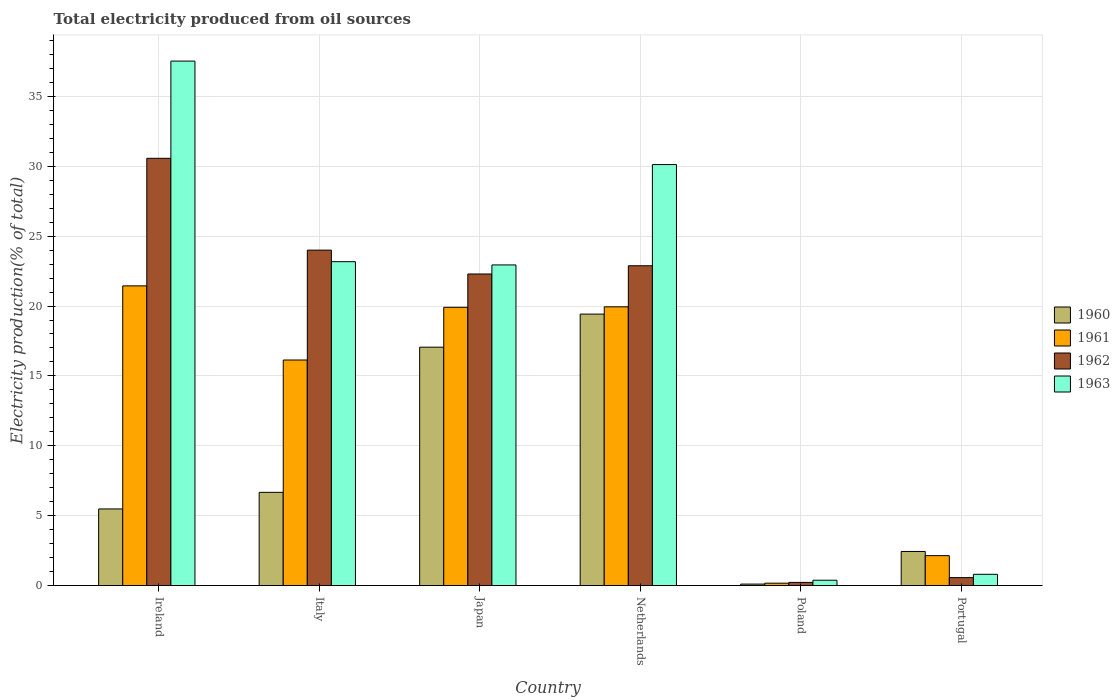How many bars are there on the 3rd tick from the left?
Your answer should be compact. 4. How many bars are there on the 4th tick from the right?
Your response must be concise. 4. What is the label of the 2nd group of bars from the left?
Make the answer very short. Italy. What is the total electricity produced in 1961 in Ireland?
Offer a very short reply. 21.44. Across all countries, what is the maximum total electricity produced in 1962?
Your response must be concise. 30.57. Across all countries, what is the minimum total electricity produced in 1961?
Your answer should be very brief. 0.17. What is the total total electricity produced in 1962 in the graph?
Offer a terse response. 100.54. What is the difference between the total electricity produced in 1961 in Netherlands and that in Portugal?
Offer a very short reply. 17.8. What is the difference between the total electricity produced in 1963 in Portugal and the total electricity produced in 1962 in Netherlands?
Your answer should be very brief. -22.08. What is the average total electricity produced in 1960 per country?
Your answer should be very brief. 8.53. What is the difference between the total electricity produced of/in 1962 and total electricity produced of/in 1961 in Japan?
Offer a terse response. 2.38. What is the ratio of the total electricity produced in 1963 in Japan to that in Netherlands?
Your answer should be very brief. 0.76. Is the total electricity produced in 1961 in Ireland less than that in Poland?
Offer a terse response. No. What is the difference between the highest and the second highest total electricity produced in 1963?
Your response must be concise. 7.4. What is the difference between the highest and the lowest total electricity produced in 1963?
Your answer should be very brief. 37.14. Is the sum of the total electricity produced in 1961 in Italy and Netherlands greater than the maximum total electricity produced in 1962 across all countries?
Keep it short and to the point. Yes. Is it the case that in every country, the sum of the total electricity produced in 1962 and total electricity produced in 1960 is greater than the sum of total electricity produced in 1963 and total electricity produced in 1961?
Your answer should be very brief. No. What does the 3rd bar from the left in Ireland represents?
Make the answer very short. 1962. Is it the case that in every country, the sum of the total electricity produced in 1963 and total electricity produced in 1961 is greater than the total electricity produced in 1960?
Your answer should be compact. Yes. Where does the legend appear in the graph?
Ensure brevity in your answer.  Center right. How are the legend labels stacked?
Make the answer very short. Vertical. What is the title of the graph?
Offer a terse response. Total electricity produced from oil sources. Does "2012" appear as one of the legend labels in the graph?
Offer a very short reply. No. What is the label or title of the Y-axis?
Provide a short and direct response. Electricity production(% of total). What is the Electricity production(% of total) of 1960 in Ireland?
Offer a very short reply. 5.48. What is the Electricity production(% of total) of 1961 in Ireland?
Offer a very short reply. 21.44. What is the Electricity production(% of total) of 1962 in Ireland?
Make the answer very short. 30.57. What is the Electricity production(% of total) of 1963 in Ireland?
Provide a short and direct response. 37.53. What is the Electricity production(% of total) in 1960 in Italy?
Your answer should be very brief. 6.67. What is the Electricity production(% of total) in 1961 in Italy?
Offer a very short reply. 16.14. What is the Electricity production(% of total) of 1962 in Italy?
Provide a succinct answer. 24. What is the Electricity production(% of total) in 1963 in Italy?
Keep it short and to the point. 23.17. What is the Electricity production(% of total) in 1960 in Japan?
Make the answer very short. 17.06. What is the Electricity production(% of total) in 1961 in Japan?
Ensure brevity in your answer.  19.91. What is the Electricity production(% of total) of 1962 in Japan?
Provide a short and direct response. 22.29. What is the Electricity production(% of total) of 1963 in Japan?
Provide a succinct answer. 22.94. What is the Electricity production(% of total) of 1960 in Netherlands?
Offer a very short reply. 19.42. What is the Electricity production(% of total) of 1961 in Netherlands?
Give a very brief answer. 19.94. What is the Electricity production(% of total) in 1962 in Netherlands?
Offer a very short reply. 22.88. What is the Electricity production(% of total) of 1963 in Netherlands?
Provide a succinct answer. 30.12. What is the Electricity production(% of total) of 1960 in Poland?
Give a very brief answer. 0.11. What is the Electricity production(% of total) of 1961 in Poland?
Your answer should be very brief. 0.17. What is the Electricity production(% of total) of 1962 in Poland?
Your answer should be very brief. 0.23. What is the Electricity production(% of total) in 1963 in Poland?
Your response must be concise. 0.38. What is the Electricity production(% of total) in 1960 in Portugal?
Your answer should be compact. 2.44. What is the Electricity production(% of total) in 1961 in Portugal?
Keep it short and to the point. 2.14. What is the Electricity production(% of total) of 1962 in Portugal?
Your answer should be compact. 0.57. What is the Electricity production(% of total) in 1963 in Portugal?
Ensure brevity in your answer.  0.81. Across all countries, what is the maximum Electricity production(% of total) of 1960?
Provide a succinct answer. 19.42. Across all countries, what is the maximum Electricity production(% of total) in 1961?
Make the answer very short. 21.44. Across all countries, what is the maximum Electricity production(% of total) of 1962?
Make the answer very short. 30.57. Across all countries, what is the maximum Electricity production(% of total) in 1963?
Ensure brevity in your answer.  37.53. Across all countries, what is the minimum Electricity production(% of total) of 1960?
Give a very brief answer. 0.11. Across all countries, what is the minimum Electricity production(% of total) in 1961?
Provide a short and direct response. 0.17. Across all countries, what is the minimum Electricity production(% of total) in 1962?
Provide a short and direct response. 0.23. Across all countries, what is the minimum Electricity production(% of total) in 1963?
Give a very brief answer. 0.38. What is the total Electricity production(% of total) in 1960 in the graph?
Make the answer very short. 51.18. What is the total Electricity production(% of total) of 1961 in the graph?
Offer a terse response. 79.75. What is the total Electricity production(% of total) of 1962 in the graph?
Provide a succinct answer. 100.54. What is the total Electricity production(% of total) in 1963 in the graph?
Provide a short and direct response. 114.95. What is the difference between the Electricity production(% of total) in 1960 in Ireland and that in Italy?
Your answer should be compact. -1.19. What is the difference between the Electricity production(% of total) in 1961 in Ireland and that in Italy?
Keep it short and to the point. 5.3. What is the difference between the Electricity production(% of total) of 1962 in Ireland and that in Italy?
Ensure brevity in your answer.  6.57. What is the difference between the Electricity production(% of total) of 1963 in Ireland and that in Italy?
Ensure brevity in your answer.  14.35. What is the difference between the Electricity production(% of total) of 1960 in Ireland and that in Japan?
Make the answer very short. -11.57. What is the difference between the Electricity production(% of total) in 1961 in Ireland and that in Japan?
Provide a short and direct response. 1.53. What is the difference between the Electricity production(% of total) of 1962 in Ireland and that in Japan?
Offer a terse response. 8.28. What is the difference between the Electricity production(% of total) of 1963 in Ireland and that in Japan?
Provide a succinct answer. 14.58. What is the difference between the Electricity production(% of total) of 1960 in Ireland and that in Netherlands?
Your answer should be very brief. -13.94. What is the difference between the Electricity production(% of total) of 1961 in Ireland and that in Netherlands?
Give a very brief answer. 1.5. What is the difference between the Electricity production(% of total) of 1962 in Ireland and that in Netherlands?
Provide a succinct answer. 7.69. What is the difference between the Electricity production(% of total) of 1963 in Ireland and that in Netherlands?
Offer a very short reply. 7.4. What is the difference between the Electricity production(% of total) of 1960 in Ireland and that in Poland?
Give a very brief answer. 5.38. What is the difference between the Electricity production(% of total) of 1961 in Ireland and that in Poland?
Provide a succinct answer. 21.27. What is the difference between the Electricity production(% of total) in 1962 in Ireland and that in Poland?
Give a very brief answer. 30.34. What is the difference between the Electricity production(% of total) in 1963 in Ireland and that in Poland?
Ensure brevity in your answer.  37.14. What is the difference between the Electricity production(% of total) of 1960 in Ireland and that in Portugal?
Your answer should be compact. 3.04. What is the difference between the Electricity production(% of total) in 1961 in Ireland and that in Portugal?
Your response must be concise. 19.3. What is the difference between the Electricity production(% of total) in 1962 in Ireland and that in Portugal?
Your answer should be compact. 30. What is the difference between the Electricity production(% of total) in 1963 in Ireland and that in Portugal?
Provide a short and direct response. 36.72. What is the difference between the Electricity production(% of total) in 1960 in Italy and that in Japan?
Provide a succinct answer. -10.39. What is the difference between the Electricity production(% of total) in 1961 in Italy and that in Japan?
Your answer should be very brief. -3.77. What is the difference between the Electricity production(% of total) in 1962 in Italy and that in Japan?
Give a very brief answer. 1.71. What is the difference between the Electricity production(% of total) in 1963 in Italy and that in Japan?
Your answer should be very brief. 0.23. What is the difference between the Electricity production(% of total) in 1960 in Italy and that in Netherlands?
Give a very brief answer. -12.75. What is the difference between the Electricity production(% of total) of 1961 in Italy and that in Netherlands?
Ensure brevity in your answer.  -3.81. What is the difference between the Electricity production(% of total) of 1962 in Italy and that in Netherlands?
Provide a succinct answer. 1.12. What is the difference between the Electricity production(% of total) of 1963 in Italy and that in Netherlands?
Your answer should be compact. -6.95. What is the difference between the Electricity production(% of total) in 1960 in Italy and that in Poland?
Your answer should be compact. 6.57. What is the difference between the Electricity production(% of total) in 1961 in Italy and that in Poland?
Make the answer very short. 15.97. What is the difference between the Electricity production(% of total) in 1962 in Italy and that in Poland?
Ensure brevity in your answer.  23.77. What is the difference between the Electricity production(% of total) in 1963 in Italy and that in Poland?
Your answer should be compact. 22.79. What is the difference between the Electricity production(% of total) of 1960 in Italy and that in Portugal?
Offer a very short reply. 4.23. What is the difference between the Electricity production(% of total) in 1961 in Italy and that in Portugal?
Your answer should be compact. 14. What is the difference between the Electricity production(% of total) of 1962 in Italy and that in Portugal?
Keep it short and to the point. 23.43. What is the difference between the Electricity production(% of total) in 1963 in Italy and that in Portugal?
Your answer should be compact. 22.37. What is the difference between the Electricity production(% of total) in 1960 in Japan and that in Netherlands?
Keep it short and to the point. -2.37. What is the difference between the Electricity production(% of total) of 1961 in Japan and that in Netherlands?
Provide a short and direct response. -0.04. What is the difference between the Electricity production(% of total) of 1962 in Japan and that in Netherlands?
Your response must be concise. -0.59. What is the difference between the Electricity production(% of total) in 1963 in Japan and that in Netherlands?
Ensure brevity in your answer.  -7.18. What is the difference between the Electricity production(% of total) of 1960 in Japan and that in Poland?
Your answer should be very brief. 16.95. What is the difference between the Electricity production(% of total) in 1961 in Japan and that in Poland?
Your response must be concise. 19.74. What is the difference between the Electricity production(% of total) of 1962 in Japan and that in Poland?
Provide a succinct answer. 22.07. What is the difference between the Electricity production(% of total) in 1963 in Japan and that in Poland?
Your answer should be compact. 22.56. What is the difference between the Electricity production(% of total) in 1960 in Japan and that in Portugal?
Ensure brevity in your answer.  14.62. What is the difference between the Electricity production(% of total) in 1961 in Japan and that in Portugal?
Make the answer very short. 17.77. What is the difference between the Electricity production(% of total) of 1962 in Japan and that in Portugal?
Make the answer very short. 21.73. What is the difference between the Electricity production(% of total) in 1963 in Japan and that in Portugal?
Provide a succinct answer. 22.14. What is the difference between the Electricity production(% of total) of 1960 in Netherlands and that in Poland?
Ensure brevity in your answer.  19.32. What is the difference between the Electricity production(% of total) of 1961 in Netherlands and that in Poland?
Offer a very short reply. 19.77. What is the difference between the Electricity production(% of total) of 1962 in Netherlands and that in Poland?
Offer a terse response. 22.66. What is the difference between the Electricity production(% of total) of 1963 in Netherlands and that in Poland?
Give a very brief answer. 29.74. What is the difference between the Electricity production(% of total) of 1960 in Netherlands and that in Portugal?
Ensure brevity in your answer.  16.98. What is the difference between the Electricity production(% of total) of 1961 in Netherlands and that in Portugal?
Your response must be concise. 17.8. What is the difference between the Electricity production(% of total) in 1962 in Netherlands and that in Portugal?
Offer a terse response. 22.31. What is the difference between the Electricity production(% of total) of 1963 in Netherlands and that in Portugal?
Make the answer very short. 29.32. What is the difference between the Electricity production(% of total) in 1960 in Poland and that in Portugal?
Provide a succinct answer. -2.33. What is the difference between the Electricity production(% of total) in 1961 in Poland and that in Portugal?
Provide a short and direct response. -1.97. What is the difference between the Electricity production(% of total) in 1962 in Poland and that in Portugal?
Keep it short and to the point. -0.34. What is the difference between the Electricity production(% of total) of 1963 in Poland and that in Portugal?
Your answer should be very brief. -0.42. What is the difference between the Electricity production(% of total) in 1960 in Ireland and the Electricity production(% of total) in 1961 in Italy?
Your answer should be compact. -10.66. What is the difference between the Electricity production(% of total) in 1960 in Ireland and the Electricity production(% of total) in 1962 in Italy?
Offer a very short reply. -18.52. What is the difference between the Electricity production(% of total) of 1960 in Ireland and the Electricity production(% of total) of 1963 in Italy?
Offer a very short reply. -17.69. What is the difference between the Electricity production(% of total) of 1961 in Ireland and the Electricity production(% of total) of 1962 in Italy?
Your answer should be very brief. -2.56. What is the difference between the Electricity production(% of total) in 1961 in Ireland and the Electricity production(% of total) in 1963 in Italy?
Make the answer very short. -1.73. What is the difference between the Electricity production(% of total) in 1962 in Ireland and the Electricity production(% of total) in 1963 in Italy?
Ensure brevity in your answer.  7.4. What is the difference between the Electricity production(% of total) in 1960 in Ireland and the Electricity production(% of total) in 1961 in Japan?
Offer a terse response. -14.43. What is the difference between the Electricity production(% of total) of 1960 in Ireland and the Electricity production(% of total) of 1962 in Japan?
Ensure brevity in your answer.  -16.81. What is the difference between the Electricity production(% of total) of 1960 in Ireland and the Electricity production(% of total) of 1963 in Japan?
Your response must be concise. -17.46. What is the difference between the Electricity production(% of total) in 1961 in Ireland and the Electricity production(% of total) in 1962 in Japan?
Provide a short and direct response. -0.85. What is the difference between the Electricity production(% of total) in 1961 in Ireland and the Electricity production(% of total) in 1963 in Japan?
Provide a succinct answer. -1.5. What is the difference between the Electricity production(% of total) in 1962 in Ireland and the Electricity production(% of total) in 1963 in Japan?
Your answer should be very brief. 7.63. What is the difference between the Electricity production(% of total) of 1960 in Ireland and the Electricity production(% of total) of 1961 in Netherlands?
Keep it short and to the point. -14.46. What is the difference between the Electricity production(% of total) of 1960 in Ireland and the Electricity production(% of total) of 1962 in Netherlands?
Make the answer very short. -17.4. What is the difference between the Electricity production(% of total) of 1960 in Ireland and the Electricity production(% of total) of 1963 in Netherlands?
Your answer should be very brief. -24.64. What is the difference between the Electricity production(% of total) in 1961 in Ireland and the Electricity production(% of total) in 1962 in Netherlands?
Your answer should be very brief. -1.44. What is the difference between the Electricity production(% of total) in 1961 in Ireland and the Electricity production(% of total) in 1963 in Netherlands?
Make the answer very short. -8.68. What is the difference between the Electricity production(% of total) of 1962 in Ireland and the Electricity production(% of total) of 1963 in Netherlands?
Give a very brief answer. 0.45. What is the difference between the Electricity production(% of total) of 1960 in Ireland and the Electricity production(% of total) of 1961 in Poland?
Your answer should be compact. 5.31. What is the difference between the Electricity production(% of total) in 1960 in Ireland and the Electricity production(% of total) in 1962 in Poland?
Provide a succinct answer. 5.26. What is the difference between the Electricity production(% of total) in 1960 in Ireland and the Electricity production(% of total) in 1963 in Poland?
Offer a terse response. 5.1. What is the difference between the Electricity production(% of total) of 1961 in Ireland and the Electricity production(% of total) of 1962 in Poland?
Offer a terse response. 21.22. What is the difference between the Electricity production(% of total) in 1961 in Ireland and the Electricity production(% of total) in 1963 in Poland?
Provide a succinct answer. 21.06. What is the difference between the Electricity production(% of total) in 1962 in Ireland and the Electricity production(% of total) in 1963 in Poland?
Provide a short and direct response. 30.19. What is the difference between the Electricity production(% of total) in 1960 in Ireland and the Electricity production(% of total) in 1961 in Portugal?
Ensure brevity in your answer.  3.34. What is the difference between the Electricity production(% of total) of 1960 in Ireland and the Electricity production(% of total) of 1962 in Portugal?
Ensure brevity in your answer.  4.91. What is the difference between the Electricity production(% of total) of 1960 in Ireland and the Electricity production(% of total) of 1963 in Portugal?
Provide a short and direct response. 4.68. What is the difference between the Electricity production(% of total) of 1961 in Ireland and the Electricity production(% of total) of 1962 in Portugal?
Provide a short and direct response. 20.87. What is the difference between the Electricity production(% of total) of 1961 in Ireland and the Electricity production(% of total) of 1963 in Portugal?
Your answer should be very brief. 20.64. What is the difference between the Electricity production(% of total) in 1962 in Ireland and the Electricity production(% of total) in 1963 in Portugal?
Ensure brevity in your answer.  29.77. What is the difference between the Electricity production(% of total) of 1960 in Italy and the Electricity production(% of total) of 1961 in Japan?
Offer a terse response. -13.24. What is the difference between the Electricity production(% of total) of 1960 in Italy and the Electricity production(% of total) of 1962 in Japan?
Your response must be concise. -15.62. What is the difference between the Electricity production(% of total) of 1960 in Italy and the Electricity production(% of total) of 1963 in Japan?
Offer a terse response. -16.27. What is the difference between the Electricity production(% of total) in 1961 in Italy and the Electricity production(% of total) in 1962 in Japan?
Your answer should be very brief. -6.15. What is the difference between the Electricity production(% of total) of 1961 in Italy and the Electricity production(% of total) of 1963 in Japan?
Ensure brevity in your answer.  -6.8. What is the difference between the Electricity production(% of total) in 1962 in Italy and the Electricity production(% of total) in 1963 in Japan?
Provide a succinct answer. 1.06. What is the difference between the Electricity production(% of total) of 1960 in Italy and the Electricity production(% of total) of 1961 in Netherlands?
Provide a succinct answer. -13.27. What is the difference between the Electricity production(% of total) in 1960 in Italy and the Electricity production(% of total) in 1962 in Netherlands?
Ensure brevity in your answer.  -16.21. What is the difference between the Electricity production(% of total) of 1960 in Italy and the Electricity production(% of total) of 1963 in Netherlands?
Your answer should be very brief. -23.45. What is the difference between the Electricity production(% of total) of 1961 in Italy and the Electricity production(% of total) of 1962 in Netherlands?
Offer a terse response. -6.74. What is the difference between the Electricity production(% of total) of 1961 in Italy and the Electricity production(% of total) of 1963 in Netherlands?
Offer a terse response. -13.98. What is the difference between the Electricity production(% of total) of 1962 in Italy and the Electricity production(% of total) of 1963 in Netherlands?
Ensure brevity in your answer.  -6.12. What is the difference between the Electricity production(% of total) of 1960 in Italy and the Electricity production(% of total) of 1961 in Poland?
Your response must be concise. 6.5. What is the difference between the Electricity production(% of total) of 1960 in Italy and the Electricity production(% of total) of 1962 in Poland?
Make the answer very short. 6.44. What is the difference between the Electricity production(% of total) in 1960 in Italy and the Electricity production(% of total) in 1963 in Poland?
Your response must be concise. 6.29. What is the difference between the Electricity production(% of total) in 1961 in Italy and the Electricity production(% of total) in 1962 in Poland?
Make the answer very short. 15.91. What is the difference between the Electricity production(% of total) in 1961 in Italy and the Electricity production(% of total) in 1963 in Poland?
Keep it short and to the point. 15.76. What is the difference between the Electricity production(% of total) in 1962 in Italy and the Electricity production(% of total) in 1963 in Poland?
Your response must be concise. 23.62. What is the difference between the Electricity production(% of total) in 1960 in Italy and the Electricity production(% of total) in 1961 in Portugal?
Your answer should be very brief. 4.53. What is the difference between the Electricity production(% of total) of 1960 in Italy and the Electricity production(% of total) of 1962 in Portugal?
Your answer should be compact. 6.1. What is the difference between the Electricity production(% of total) of 1960 in Italy and the Electricity production(% of total) of 1963 in Portugal?
Your response must be concise. 5.87. What is the difference between the Electricity production(% of total) in 1961 in Italy and the Electricity production(% of total) in 1962 in Portugal?
Your response must be concise. 15.57. What is the difference between the Electricity production(% of total) in 1961 in Italy and the Electricity production(% of total) in 1963 in Portugal?
Offer a terse response. 15.33. What is the difference between the Electricity production(% of total) in 1962 in Italy and the Electricity production(% of total) in 1963 in Portugal?
Offer a terse response. 23.19. What is the difference between the Electricity production(% of total) of 1960 in Japan and the Electricity production(% of total) of 1961 in Netherlands?
Ensure brevity in your answer.  -2.89. What is the difference between the Electricity production(% of total) of 1960 in Japan and the Electricity production(% of total) of 1962 in Netherlands?
Give a very brief answer. -5.83. What is the difference between the Electricity production(% of total) in 1960 in Japan and the Electricity production(% of total) in 1963 in Netherlands?
Your response must be concise. -13.07. What is the difference between the Electricity production(% of total) in 1961 in Japan and the Electricity production(% of total) in 1962 in Netherlands?
Your answer should be very brief. -2.97. What is the difference between the Electricity production(% of total) in 1961 in Japan and the Electricity production(% of total) in 1963 in Netherlands?
Ensure brevity in your answer.  -10.21. What is the difference between the Electricity production(% of total) of 1962 in Japan and the Electricity production(% of total) of 1963 in Netherlands?
Make the answer very short. -7.83. What is the difference between the Electricity production(% of total) in 1960 in Japan and the Electricity production(% of total) in 1961 in Poland?
Ensure brevity in your answer.  16.89. What is the difference between the Electricity production(% of total) in 1960 in Japan and the Electricity production(% of total) in 1962 in Poland?
Provide a short and direct response. 16.83. What is the difference between the Electricity production(% of total) in 1960 in Japan and the Electricity production(% of total) in 1963 in Poland?
Your response must be concise. 16.67. What is the difference between the Electricity production(% of total) in 1961 in Japan and the Electricity production(% of total) in 1962 in Poland?
Provide a short and direct response. 19.68. What is the difference between the Electricity production(% of total) of 1961 in Japan and the Electricity production(% of total) of 1963 in Poland?
Provide a short and direct response. 19.53. What is the difference between the Electricity production(% of total) of 1962 in Japan and the Electricity production(% of total) of 1963 in Poland?
Your answer should be very brief. 21.91. What is the difference between the Electricity production(% of total) in 1960 in Japan and the Electricity production(% of total) in 1961 in Portugal?
Your answer should be compact. 14.91. What is the difference between the Electricity production(% of total) in 1960 in Japan and the Electricity production(% of total) in 1962 in Portugal?
Ensure brevity in your answer.  16.49. What is the difference between the Electricity production(% of total) of 1960 in Japan and the Electricity production(% of total) of 1963 in Portugal?
Ensure brevity in your answer.  16.25. What is the difference between the Electricity production(% of total) in 1961 in Japan and the Electricity production(% of total) in 1962 in Portugal?
Provide a short and direct response. 19.34. What is the difference between the Electricity production(% of total) of 1961 in Japan and the Electricity production(% of total) of 1963 in Portugal?
Offer a terse response. 19.1. What is the difference between the Electricity production(% of total) of 1962 in Japan and the Electricity production(% of total) of 1963 in Portugal?
Your answer should be very brief. 21.49. What is the difference between the Electricity production(% of total) in 1960 in Netherlands and the Electricity production(% of total) in 1961 in Poland?
Provide a succinct answer. 19.25. What is the difference between the Electricity production(% of total) in 1960 in Netherlands and the Electricity production(% of total) in 1962 in Poland?
Provide a succinct answer. 19.2. What is the difference between the Electricity production(% of total) of 1960 in Netherlands and the Electricity production(% of total) of 1963 in Poland?
Offer a very short reply. 19.04. What is the difference between the Electricity production(% of total) in 1961 in Netherlands and the Electricity production(% of total) in 1962 in Poland?
Make the answer very short. 19.72. What is the difference between the Electricity production(% of total) of 1961 in Netherlands and the Electricity production(% of total) of 1963 in Poland?
Give a very brief answer. 19.56. What is the difference between the Electricity production(% of total) of 1962 in Netherlands and the Electricity production(% of total) of 1963 in Poland?
Make the answer very short. 22.5. What is the difference between the Electricity production(% of total) in 1960 in Netherlands and the Electricity production(% of total) in 1961 in Portugal?
Your answer should be compact. 17.28. What is the difference between the Electricity production(% of total) of 1960 in Netherlands and the Electricity production(% of total) of 1962 in Portugal?
Offer a terse response. 18.86. What is the difference between the Electricity production(% of total) in 1960 in Netherlands and the Electricity production(% of total) in 1963 in Portugal?
Offer a very short reply. 18.62. What is the difference between the Electricity production(% of total) of 1961 in Netherlands and the Electricity production(% of total) of 1962 in Portugal?
Provide a succinct answer. 19.38. What is the difference between the Electricity production(% of total) in 1961 in Netherlands and the Electricity production(% of total) in 1963 in Portugal?
Provide a succinct answer. 19.14. What is the difference between the Electricity production(% of total) in 1962 in Netherlands and the Electricity production(% of total) in 1963 in Portugal?
Offer a terse response. 22.08. What is the difference between the Electricity production(% of total) of 1960 in Poland and the Electricity production(% of total) of 1961 in Portugal?
Keep it short and to the point. -2.04. What is the difference between the Electricity production(% of total) of 1960 in Poland and the Electricity production(% of total) of 1962 in Portugal?
Keep it short and to the point. -0.46. What is the difference between the Electricity production(% of total) in 1960 in Poland and the Electricity production(% of total) in 1963 in Portugal?
Keep it short and to the point. -0.7. What is the difference between the Electricity production(% of total) of 1961 in Poland and the Electricity production(% of total) of 1962 in Portugal?
Keep it short and to the point. -0.4. What is the difference between the Electricity production(% of total) in 1961 in Poland and the Electricity production(% of total) in 1963 in Portugal?
Your answer should be very brief. -0.63. What is the difference between the Electricity production(% of total) in 1962 in Poland and the Electricity production(% of total) in 1963 in Portugal?
Offer a very short reply. -0.58. What is the average Electricity production(% of total) in 1960 per country?
Offer a terse response. 8.53. What is the average Electricity production(% of total) in 1961 per country?
Provide a short and direct response. 13.29. What is the average Electricity production(% of total) of 1962 per country?
Provide a succinct answer. 16.76. What is the average Electricity production(% of total) in 1963 per country?
Offer a very short reply. 19.16. What is the difference between the Electricity production(% of total) of 1960 and Electricity production(% of total) of 1961 in Ireland?
Offer a terse response. -15.96. What is the difference between the Electricity production(% of total) of 1960 and Electricity production(% of total) of 1962 in Ireland?
Ensure brevity in your answer.  -25.09. What is the difference between the Electricity production(% of total) in 1960 and Electricity production(% of total) in 1963 in Ireland?
Your answer should be compact. -32.04. What is the difference between the Electricity production(% of total) of 1961 and Electricity production(% of total) of 1962 in Ireland?
Give a very brief answer. -9.13. What is the difference between the Electricity production(% of total) in 1961 and Electricity production(% of total) in 1963 in Ireland?
Provide a short and direct response. -16.08. What is the difference between the Electricity production(% of total) of 1962 and Electricity production(% of total) of 1963 in Ireland?
Ensure brevity in your answer.  -6.95. What is the difference between the Electricity production(% of total) of 1960 and Electricity production(% of total) of 1961 in Italy?
Keep it short and to the point. -9.47. What is the difference between the Electricity production(% of total) in 1960 and Electricity production(% of total) in 1962 in Italy?
Your answer should be compact. -17.33. What is the difference between the Electricity production(% of total) in 1960 and Electricity production(% of total) in 1963 in Italy?
Make the answer very short. -16.5. What is the difference between the Electricity production(% of total) in 1961 and Electricity production(% of total) in 1962 in Italy?
Offer a very short reply. -7.86. What is the difference between the Electricity production(% of total) in 1961 and Electricity production(% of total) in 1963 in Italy?
Give a very brief answer. -7.04. What is the difference between the Electricity production(% of total) in 1962 and Electricity production(% of total) in 1963 in Italy?
Your response must be concise. 0.83. What is the difference between the Electricity production(% of total) in 1960 and Electricity production(% of total) in 1961 in Japan?
Offer a terse response. -2.85. What is the difference between the Electricity production(% of total) of 1960 and Electricity production(% of total) of 1962 in Japan?
Ensure brevity in your answer.  -5.24. What is the difference between the Electricity production(% of total) of 1960 and Electricity production(% of total) of 1963 in Japan?
Offer a very short reply. -5.89. What is the difference between the Electricity production(% of total) of 1961 and Electricity production(% of total) of 1962 in Japan?
Give a very brief answer. -2.38. What is the difference between the Electricity production(% of total) of 1961 and Electricity production(% of total) of 1963 in Japan?
Ensure brevity in your answer.  -3.03. What is the difference between the Electricity production(% of total) of 1962 and Electricity production(% of total) of 1963 in Japan?
Your response must be concise. -0.65. What is the difference between the Electricity production(% of total) of 1960 and Electricity production(% of total) of 1961 in Netherlands?
Give a very brief answer. -0.52. What is the difference between the Electricity production(% of total) of 1960 and Electricity production(% of total) of 1962 in Netherlands?
Offer a very short reply. -3.46. What is the difference between the Electricity production(% of total) in 1960 and Electricity production(% of total) in 1963 in Netherlands?
Provide a succinct answer. -10.7. What is the difference between the Electricity production(% of total) of 1961 and Electricity production(% of total) of 1962 in Netherlands?
Offer a terse response. -2.94. What is the difference between the Electricity production(% of total) of 1961 and Electricity production(% of total) of 1963 in Netherlands?
Your answer should be compact. -10.18. What is the difference between the Electricity production(% of total) in 1962 and Electricity production(% of total) in 1963 in Netherlands?
Ensure brevity in your answer.  -7.24. What is the difference between the Electricity production(% of total) of 1960 and Electricity production(% of total) of 1961 in Poland?
Your answer should be compact. -0.06. What is the difference between the Electricity production(% of total) of 1960 and Electricity production(% of total) of 1962 in Poland?
Provide a short and direct response. -0.12. What is the difference between the Electricity production(% of total) of 1960 and Electricity production(% of total) of 1963 in Poland?
Make the answer very short. -0.28. What is the difference between the Electricity production(% of total) in 1961 and Electricity production(% of total) in 1962 in Poland?
Provide a succinct answer. -0.06. What is the difference between the Electricity production(% of total) in 1961 and Electricity production(% of total) in 1963 in Poland?
Make the answer very short. -0.21. What is the difference between the Electricity production(% of total) of 1962 and Electricity production(% of total) of 1963 in Poland?
Give a very brief answer. -0.16. What is the difference between the Electricity production(% of total) in 1960 and Electricity production(% of total) in 1961 in Portugal?
Make the answer very short. 0.3. What is the difference between the Electricity production(% of total) in 1960 and Electricity production(% of total) in 1962 in Portugal?
Give a very brief answer. 1.87. What is the difference between the Electricity production(% of total) in 1960 and Electricity production(% of total) in 1963 in Portugal?
Your answer should be very brief. 1.63. What is the difference between the Electricity production(% of total) of 1961 and Electricity production(% of total) of 1962 in Portugal?
Offer a very short reply. 1.57. What is the difference between the Electricity production(% of total) of 1961 and Electricity production(% of total) of 1963 in Portugal?
Your answer should be compact. 1.34. What is the difference between the Electricity production(% of total) in 1962 and Electricity production(% of total) in 1963 in Portugal?
Give a very brief answer. -0.24. What is the ratio of the Electricity production(% of total) of 1960 in Ireland to that in Italy?
Your answer should be compact. 0.82. What is the ratio of the Electricity production(% of total) in 1961 in Ireland to that in Italy?
Provide a succinct answer. 1.33. What is the ratio of the Electricity production(% of total) of 1962 in Ireland to that in Italy?
Your answer should be very brief. 1.27. What is the ratio of the Electricity production(% of total) of 1963 in Ireland to that in Italy?
Offer a very short reply. 1.62. What is the ratio of the Electricity production(% of total) of 1960 in Ireland to that in Japan?
Your response must be concise. 0.32. What is the ratio of the Electricity production(% of total) in 1961 in Ireland to that in Japan?
Provide a succinct answer. 1.08. What is the ratio of the Electricity production(% of total) of 1962 in Ireland to that in Japan?
Your answer should be compact. 1.37. What is the ratio of the Electricity production(% of total) in 1963 in Ireland to that in Japan?
Give a very brief answer. 1.64. What is the ratio of the Electricity production(% of total) of 1960 in Ireland to that in Netherlands?
Your answer should be very brief. 0.28. What is the ratio of the Electricity production(% of total) of 1961 in Ireland to that in Netherlands?
Make the answer very short. 1.08. What is the ratio of the Electricity production(% of total) in 1962 in Ireland to that in Netherlands?
Your answer should be compact. 1.34. What is the ratio of the Electricity production(% of total) in 1963 in Ireland to that in Netherlands?
Provide a short and direct response. 1.25. What is the ratio of the Electricity production(% of total) in 1960 in Ireland to that in Poland?
Give a very brief answer. 51.78. What is the ratio of the Electricity production(% of total) in 1961 in Ireland to that in Poland?
Keep it short and to the point. 125.7. What is the ratio of the Electricity production(% of total) in 1962 in Ireland to that in Poland?
Offer a very short reply. 135.14. What is the ratio of the Electricity production(% of total) in 1963 in Ireland to that in Poland?
Ensure brevity in your answer.  98.31. What is the ratio of the Electricity production(% of total) of 1960 in Ireland to that in Portugal?
Your response must be concise. 2.25. What is the ratio of the Electricity production(% of total) in 1961 in Ireland to that in Portugal?
Provide a succinct answer. 10.01. What is the ratio of the Electricity production(% of total) of 1962 in Ireland to that in Portugal?
Keep it short and to the point. 53.8. What is the ratio of the Electricity production(% of total) of 1963 in Ireland to that in Portugal?
Your response must be concise. 46.6. What is the ratio of the Electricity production(% of total) in 1960 in Italy to that in Japan?
Keep it short and to the point. 0.39. What is the ratio of the Electricity production(% of total) of 1961 in Italy to that in Japan?
Keep it short and to the point. 0.81. What is the ratio of the Electricity production(% of total) of 1962 in Italy to that in Japan?
Give a very brief answer. 1.08. What is the ratio of the Electricity production(% of total) of 1960 in Italy to that in Netherlands?
Your answer should be very brief. 0.34. What is the ratio of the Electricity production(% of total) in 1961 in Italy to that in Netherlands?
Your answer should be very brief. 0.81. What is the ratio of the Electricity production(% of total) of 1962 in Italy to that in Netherlands?
Your response must be concise. 1.05. What is the ratio of the Electricity production(% of total) in 1963 in Italy to that in Netherlands?
Ensure brevity in your answer.  0.77. What is the ratio of the Electricity production(% of total) of 1960 in Italy to that in Poland?
Offer a terse response. 63.01. What is the ratio of the Electricity production(% of total) in 1961 in Italy to that in Poland?
Offer a very short reply. 94.6. What is the ratio of the Electricity production(% of total) in 1962 in Italy to that in Poland?
Provide a succinct answer. 106.09. What is the ratio of the Electricity production(% of total) in 1963 in Italy to that in Poland?
Your answer should be compact. 60.72. What is the ratio of the Electricity production(% of total) in 1960 in Italy to that in Portugal?
Keep it short and to the point. 2.73. What is the ratio of the Electricity production(% of total) in 1961 in Italy to that in Portugal?
Make the answer very short. 7.54. What is the ratio of the Electricity production(% of total) in 1962 in Italy to that in Portugal?
Provide a succinct answer. 42.24. What is the ratio of the Electricity production(% of total) of 1963 in Italy to that in Portugal?
Provide a short and direct response. 28.78. What is the ratio of the Electricity production(% of total) in 1960 in Japan to that in Netherlands?
Your answer should be very brief. 0.88. What is the ratio of the Electricity production(% of total) in 1961 in Japan to that in Netherlands?
Keep it short and to the point. 1. What is the ratio of the Electricity production(% of total) in 1962 in Japan to that in Netherlands?
Provide a succinct answer. 0.97. What is the ratio of the Electricity production(% of total) in 1963 in Japan to that in Netherlands?
Make the answer very short. 0.76. What is the ratio of the Electricity production(% of total) of 1960 in Japan to that in Poland?
Offer a very short reply. 161.11. What is the ratio of the Electricity production(% of total) of 1961 in Japan to that in Poland?
Offer a very short reply. 116.7. What is the ratio of the Electricity production(% of total) in 1962 in Japan to that in Poland?
Give a very brief answer. 98.55. What is the ratio of the Electricity production(% of total) in 1963 in Japan to that in Poland?
Provide a short and direct response. 60.11. What is the ratio of the Electricity production(% of total) of 1960 in Japan to that in Portugal?
Your answer should be very brief. 6.99. What is the ratio of the Electricity production(% of total) in 1961 in Japan to that in Portugal?
Offer a very short reply. 9.3. What is the ratio of the Electricity production(% of total) in 1962 in Japan to that in Portugal?
Your response must be concise. 39.24. What is the ratio of the Electricity production(% of total) in 1963 in Japan to that in Portugal?
Your response must be concise. 28.49. What is the ratio of the Electricity production(% of total) of 1960 in Netherlands to that in Poland?
Provide a short and direct response. 183.47. What is the ratio of the Electricity production(% of total) in 1961 in Netherlands to that in Poland?
Offer a very short reply. 116.91. What is the ratio of the Electricity production(% of total) of 1962 in Netherlands to that in Poland?
Ensure brevity in your answer.  101.15. What is the ratio of the Electricity production(% of total) in 1963 in Netherlands to that in Poland?
Ensure brevity in your answer.  78.92. What is the ratio of the Electricity production(% of total) of 1960 in Netherlands to that in Portugal?
Ensure brevity in your answer.  7.96. What is the ratio of the Electricity production(% of total) of 1961 in Netherlands to that in Portugal?
Provide a succinct answer. 9.31. What is the ratio of the Electricity production(% of total) in 1962 in Netherlands to that in Portugal?
Your answer should be very brief. 40.27. What is the ratio of the Electricity production(% of total) in 1963 in Netherlands to that in Portugal?
Keep it short and to the point. 37.4. What is the ratio of the Electricity production(% of total) in 1960 in Poland to that in Portugal?
Your answer should be compact. 0.04. What is the ratio of the Electricity production(% of total) in 1961 in Poland to that in Portugal?
Make the answer very short. 0.08. What is the ratio of the Electricity production(% of total) in 1962 in Poland to that in Portugal?
Make the answer very short. 0.4. What is the ratio of the Electricity production(% of total) in 1963 in Poland to that in Portugal?
Offer a very short reply. 0.47. What is the difference between the highest and the second highest Electricity production(% of total) in 1960?
Provide a short and direct response. 2.37. What is the difference between the highest and the second highest Electricity production(% of total) of 1961?
Ensure brevity in your answer.  1.5. What is the difference between the highest and the second highest Electricity production(% of total) in 1962?
Your response must be concise. 6.57. What is the difference between the highest and the second highest Electricity production(% of total) of 1963?
Your answer should be compact. 7.4. What is the difference between the highest and the lowest Electricity production(% of total) of 1960?
Give a very brief answer. 19.32. What is the difference between the highest and the lowest Electricity production(% of total) in 1961?
Your response must be concise. 21.27. What is the difference between the highest and the lowest Electricity production(% of total) in 1962?
Provide a succinct answer. 30.34. What is the difference between the highest and the lowest Electricity production(% of total) in 1963?
Offer a very short reply. 37.14. 